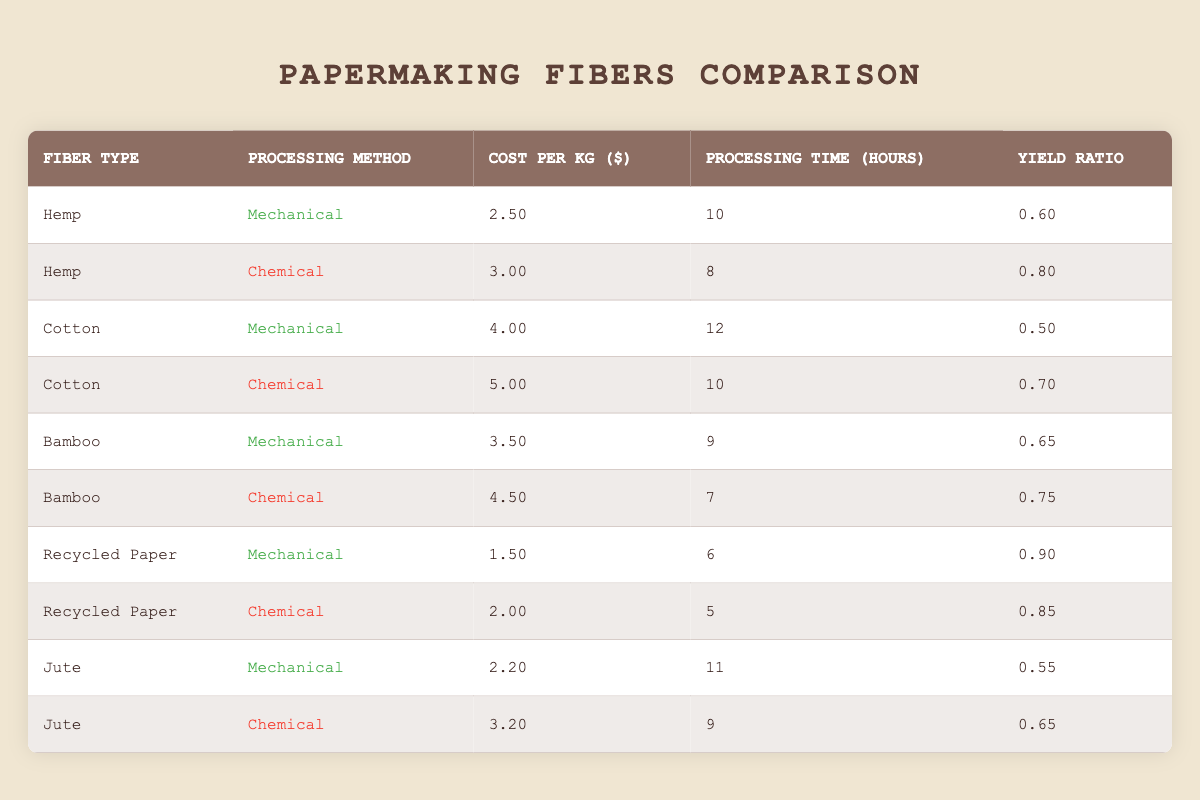What is the cost per kg of Bamboo using the Chemical processing method? From the table, I locate the row for Bamboo under the Chemical processing method, which lists the cost as 4.5 per kg.
Answer: 4.5 Which processing method for Recycled Paper has a lower cost per kg? In the table, the cost for the Mechanical processing method is 1.5 per kg, and the Chemical method is 2.0 per kg. Since 1.5 is less than 2.0, Mechanical is the cheaper option.
Answer: Mechanical What is the yield ratio for Cotton processed mechanically? Looking at the Cotton row with the Mechanical method, the yield ratio is stated as 0.5 in the table.
Answer: 0.5 Which fiber type has the highest yield ratio when processed chemically? By examining the Chemical processing rows in the table, the yield ratios are as follows: Hemp (0.8), Cotton (0.7), Bamboo (0.75), Recycled Paper (0.85), and Jute (0.65). The maximum yield ratio is 0.85, associated with Recycled Paper.
Answer: Recycled Paper Is the cost per kg for Hemp processed mechanically higher than that of Cotton processed chemically? The cost for Hemp (Mechanical) is 2.5, and for Cotton (Chemical) it is 5.0. Since 2.5 is less than 5.0, the statement is false.
Answer: No What is the average processing time for all Mechanical processing methods across the listed fibers? Extracting the processing times for the Mechanical methods: Hemp (10), Cotton (12), Bamboo (9), Recycled Paper (6), Jute (11), I sum these up: 10 + 12 + 9 + 6 + 11 = 48. There are 5 fibers, so the average is 48/5 = 9.6 hours.
Answer: 9.6 What is the cost difference between the cheapest and the most expensive fiber method? Analyzing the costs, the cheapest is Recycled Paper (Mechanical) at 1.5, and the most expensive is Cotton (Chemical) at 5.0. The difference is 5.0 - 1.5 = 3.5.
Answer: 3.5 True or False: The yield ratio for Hemp when processed chemically is equal to that of Bamboo when processed mechanically. The yield ratio for Hemp (Chemical) is 0.8, while for Bamboo (Mechanical), it is 0.65. As 0.8 is not equal to 0.65, the statement is false.
Answer: False Which fiber type requires the longest processing time among all listed methods? Assessing the processing times, Cotton (Mechanical) at 12 hours is the longest. I compare all others and find they are all shorter (maximum is 12 hours).
Answer: Cotton 